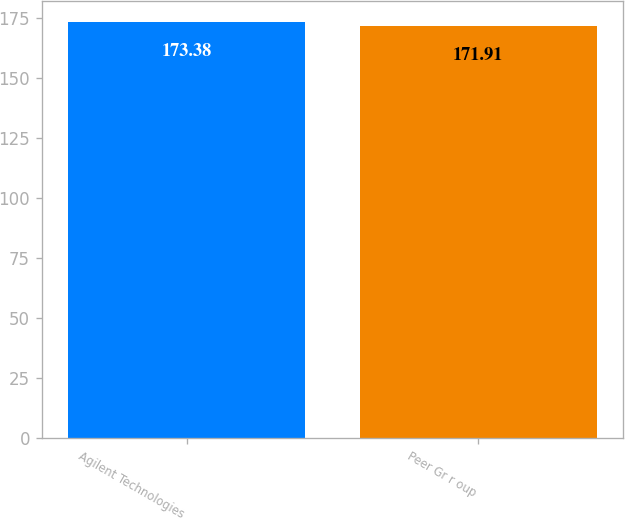Convert chart to OTSL. <chart><loc_0><loc_0><loc_500><loc_500><bar_chart><fcel>Agilent Technologies<fcel>Peer Gr r oup<nl><fcel>173.38<fcel>171.91<nl></chart> 